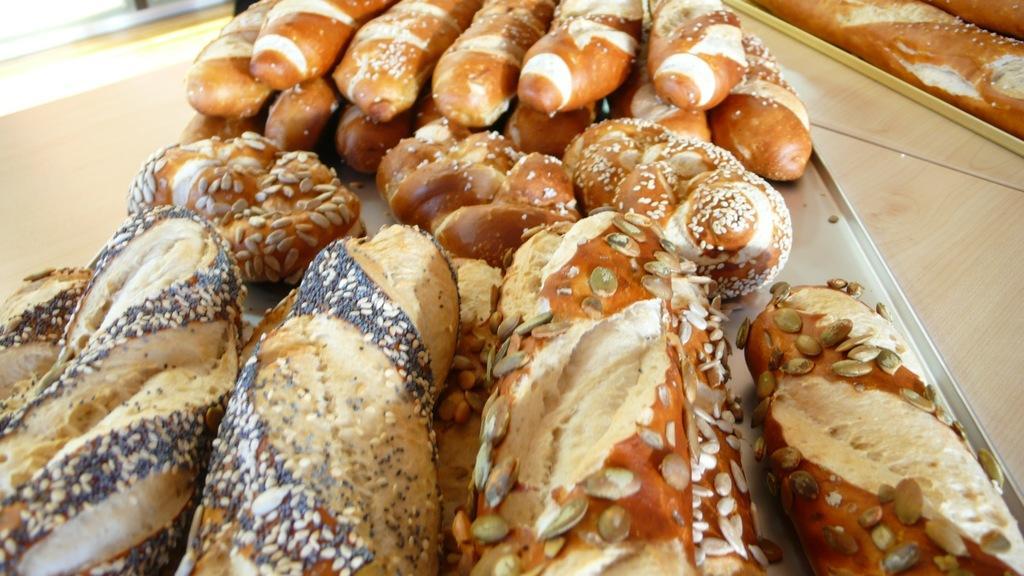Please provide a concise description of this image. In this image I can see few food items in the tray and the food is in brown, cream and black color and the tray is on the wooden surface. 